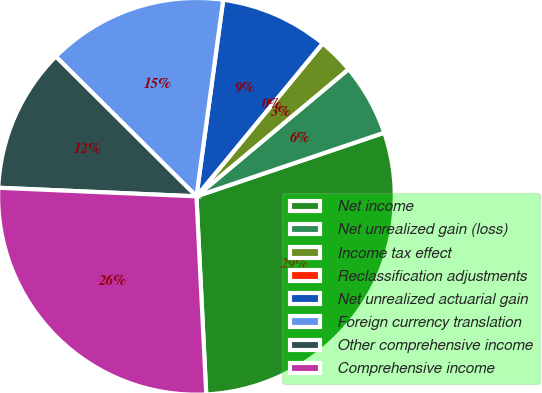Convert chart to OTSL. <chart><loc_0><loc_0><loc_500><loc_500><pie_chart><fcel>Net income<fcel>Net unrealized gain (loss)<fcel>Income tax effect<fcel>Reclassification adjustments<fcel>Net unrealized actuarial gain<fcel>Foreign currency translation<fcel>Other comprehensive income<fcel>Comprehensive income<nl><fcel>29.41%<fcel>5.88%<fcel>2.94%<fcel>0.0%<fcel>8.82%<fcel>14.7%<fcel>11.76%<fcel>26.47%<nl></chart> 